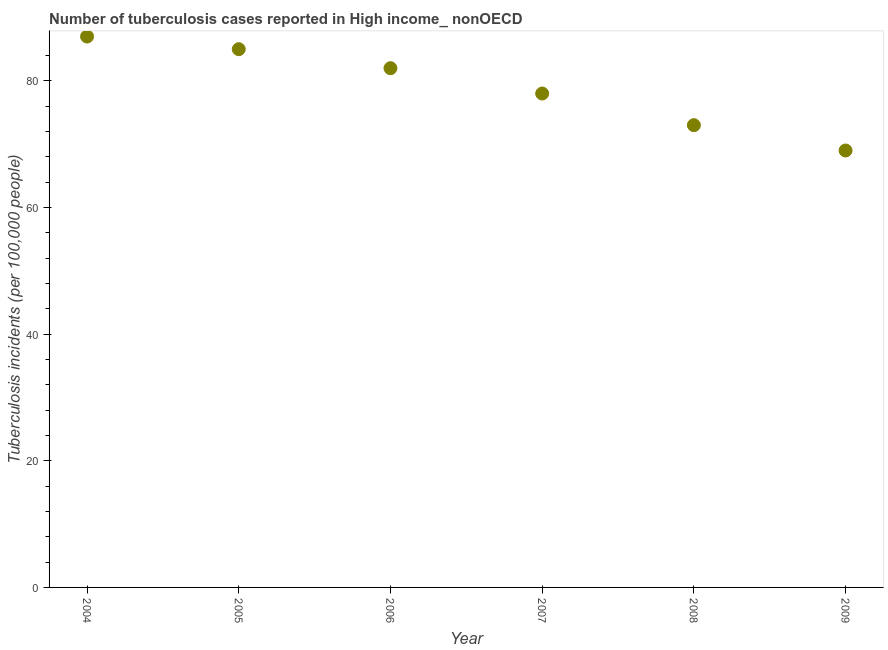What is the number of tuberculosis incidents in 2007?
Your response must be concise. 78. Across all years, what is the maximum number of tuberculosis incidents?
Your answer should be very brief. 87. Across all years, what is the minimum number of tuberculosis incidents?
Your answer should be compact. 69. In which year was the number of tuberculosis incidents maximum?
Provide a short and direct response. 2004. In which year was the number of tuberculosis incidents minimum?
Your answer should be compact. 2009. What is the sum of the number of tuberculosis incidents?
Keep it short and to the point. 474. What is the difference between the number of tuberculosis incidents in 2004 and 2008?
Provide a succinct answer. 14. What is the average number of tuberculosis incidents per year?
Offer a very short reply. 79. What is the median number of tuberculosis incidents?
Keep it short and to the point. 80. In how many years, is the number of tuberculosis incidents greater than 52 ?
Ensure brevity in your answer.  6. What is the ratio of the number of tuberculosis incidents in 2005 to that in 2006?
Give a very brief answer. 1.04. Is the number of tuberculosis incidents in 2008 less than that in 2009?
Keep it short and to the point. No. Is the sum of the number of tuberculosis incidents in 2006 and 2007 greater than the maximum number of tuberculosis incidents across all years?
Your answer should be compact. Yes. What is the difference between the highest and the lowest number of tuberculosis incidents?
Offer a very short reply. 18. In how many years, is the number of tuberculosis incidents greater than the average number of tuberculosis incidents taken over all years?
Ensure brevity in your answer.  3. How many years are there in the graph?
Give a very brief answer. 6. Are the values on the major ticks of Y-axis written in scientific E-notation?
Offer a terse response. No. Does the graph contain any zero values?
Make the answer very short. No. What is the title of the graph?
Your answer should be very brief. Number of tuberculosis cases reported in High income_ nonOECD. What is the label or title of the X-axis?
Your answer should be very brief. Year. What is the label or title of the Y-axis?
Your answer should be compact. Tuberculosis incidents (per 100,0 people). What is the Tuberculosis incidents (per 100,000 people) in 2007?
Offer a terse response. 78. What is the difference between the Tuberculosis incidents (per 100,000 people) in 2004 and 2006?
Offer a terse response. 5. What is the difference between the Tuberculosis incidents (per 100,000 people) in 2004 and 2007?
Offer a very short reply. 9. What is the difference between the Tuberculosis incidents (per 100,000 people) in 2005 and 2006?
Offer a terse response. 3. What is the difference between the Tuberculosis incidents (per 100,000 people) in 2005 and 2007?
Make the answer very short. 7. What is the difference between the Tuberculosis incidents (per 100,000 people) in 2006 and 2007?
Make the answer very short. 4. What is the difference between the Tuberculosis incidents (per 100,000 people) in 2006 and 2009?
Provide a short and direct response. 13. What is the difference between the Tuberculosis incidents (per 100,000 people) in 2007 and 2009?
Offer a terse response. 9. What is the ratio of the Tuberculosis incidents (per 100,000 people) in 2004 to that in 2005?
Provide a short and direct response. 1.02. What is the ratio of the Tuberculosis incidents (per 100,000 people) in 2004 to that in 2006?
Your answer should be very brief. 1.06. What is the ratio of the Tuberculosis incidents (per 100,000 people) in 2004 to that in 2007?
Make the answer very short. 1.11. What is the ratio of the Tuberculosis incidents (per 100,000 people) in 2004 to that in 2008?
Provide a succinct answer. 1.19. What is the ratio of the Tuberculosis incidents (per 100,000 people) in 2004 to that in 2009?
Make the answer very short. 1.26. What is the ratio of the Tuberculosis incidents (per 100,000 people) in 2005 to that in 2006?
Offer a terse response. 1.04. What is the ratio of the Tuberculosis incidents (per 100,000 people) in 2005 to that in 2007?
Provide a short and direct response. 1.09. What is the ratio of the Tuberculosis incidents (per 100,000 people) in 2005 to that in 2008?
Provide a short and direct response. 1.16. What is the ratio of the Tuberculosis incidents (per 100,000 people) in 2005 to that in 2009?
Offer a very short reply. 1.23. What is the ratio of the Tuberculosis incidents (per 100,000 people) in 2006 to that in 2007?
Offer a terse response. 1.05. What is the ratio of the Tuberculosis incidents (per 100,000 people) in 2006 to that in 2008?
Provide a succinct answer. 1.12. What is the ratio of the Tuberculosis incidents (per 100,000 people) in 2006 to that in 2009?
Your answer should be compact. 1.19. What is the ratio of the Tuberculosis incidents (per 100,000 people) in 2007 to that in 2008?
Offer a very short reply. 1.07. What is the ratio of the Tuberculosis incidents (per 100,000 people) in 2007 to that in 2009?
Your response must be concise. 1.13. What is the ratio of the Tuberculosis incidents (per 100,000 people) in 2008 to that in 2009?
Keep it short and to the point. 1.06. 